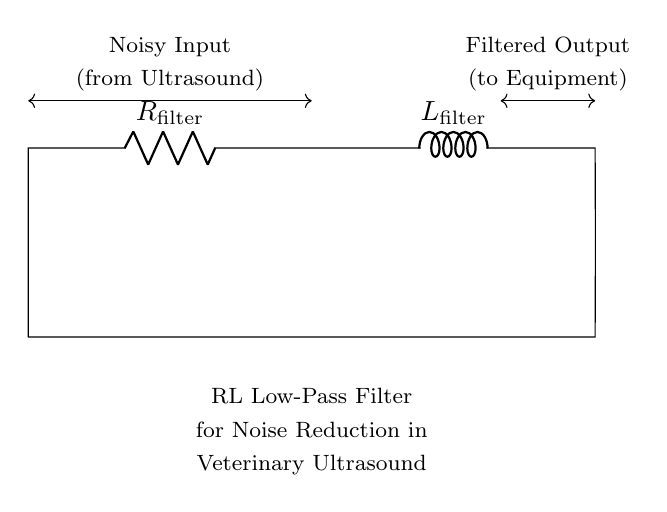What are the components in this circuit? The circuit contains a resistor and an inductor, identifiable by the symbols used in the schematic. The resistor is labeled with R and the inductor with L.
Answer: resistor and inductor What is the purpose of this RL filter circuit? The circuit serves as a low-pass filter designed to reduce noise from the input signal coming from the ultrasound equipment. This function is indicated in the notes below the circuit.
Answer: noise reduction What is the current direction in an RL circuit? The current generally flows from the noise input, through the resistor, then through the inductor, and towards the filtered output. This is visualized by the direction of the lines in the circuit schematic.
Answer: left to right What type of filter does this RL circuit create? The circuit is configured as a low-pass filter, which allows low-frequency signals to pass through while attenuating higher-frequency noise, as indicated in the circuit's description.
Answer: low-pass filter What is the relationship between resistance and inductance in this circuit? In an RL filter, the resistance (R) and inductance (L) work together to determine the cutoff frequency; the voltage across the inductor increases with increasing frequency, while the voltage across the resistor decreases. This implies that their values affect the filter's performance in filtering out noise.
Answer: affects cutoff frequency How is the filtered output connected in the circuit? The filtered output is connected directly after the inductor, providing the processed signal output to the intended equipment; this is notably indicated by its labeling in the circuit schematic.
Answer: directly after the inductor What does L represent in this circuit? L represents the inductance of the inductor component within the RL filter circuit; it determines the inductor's ability to store energy in the magnetic field.
Answer: inductance 